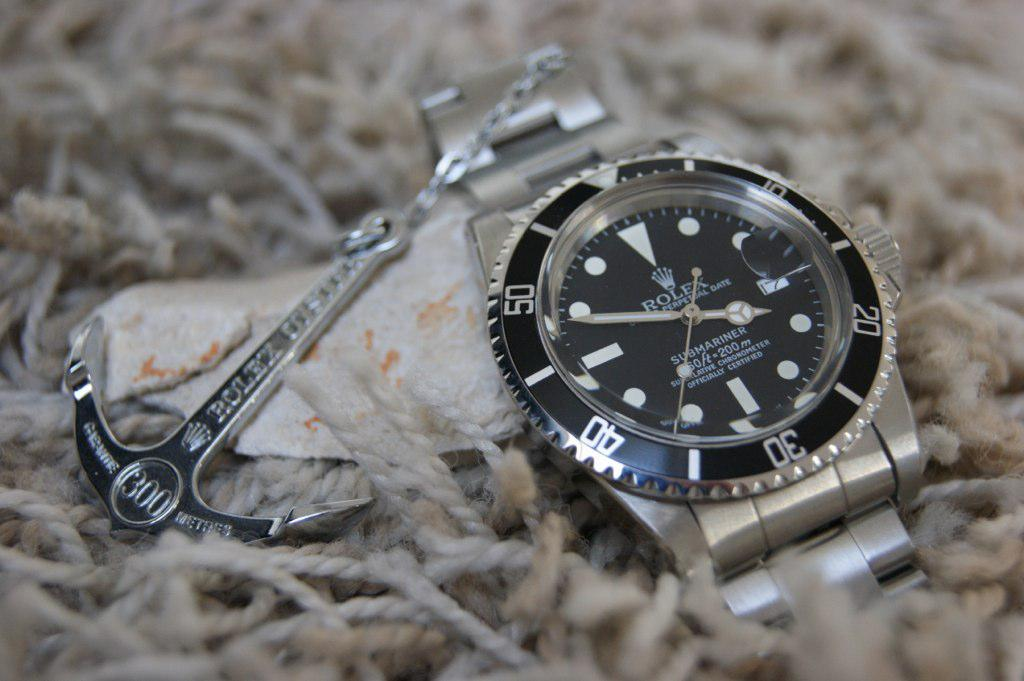<image>
Summarize the visual content of the image. a watch that has the number 30 on it 